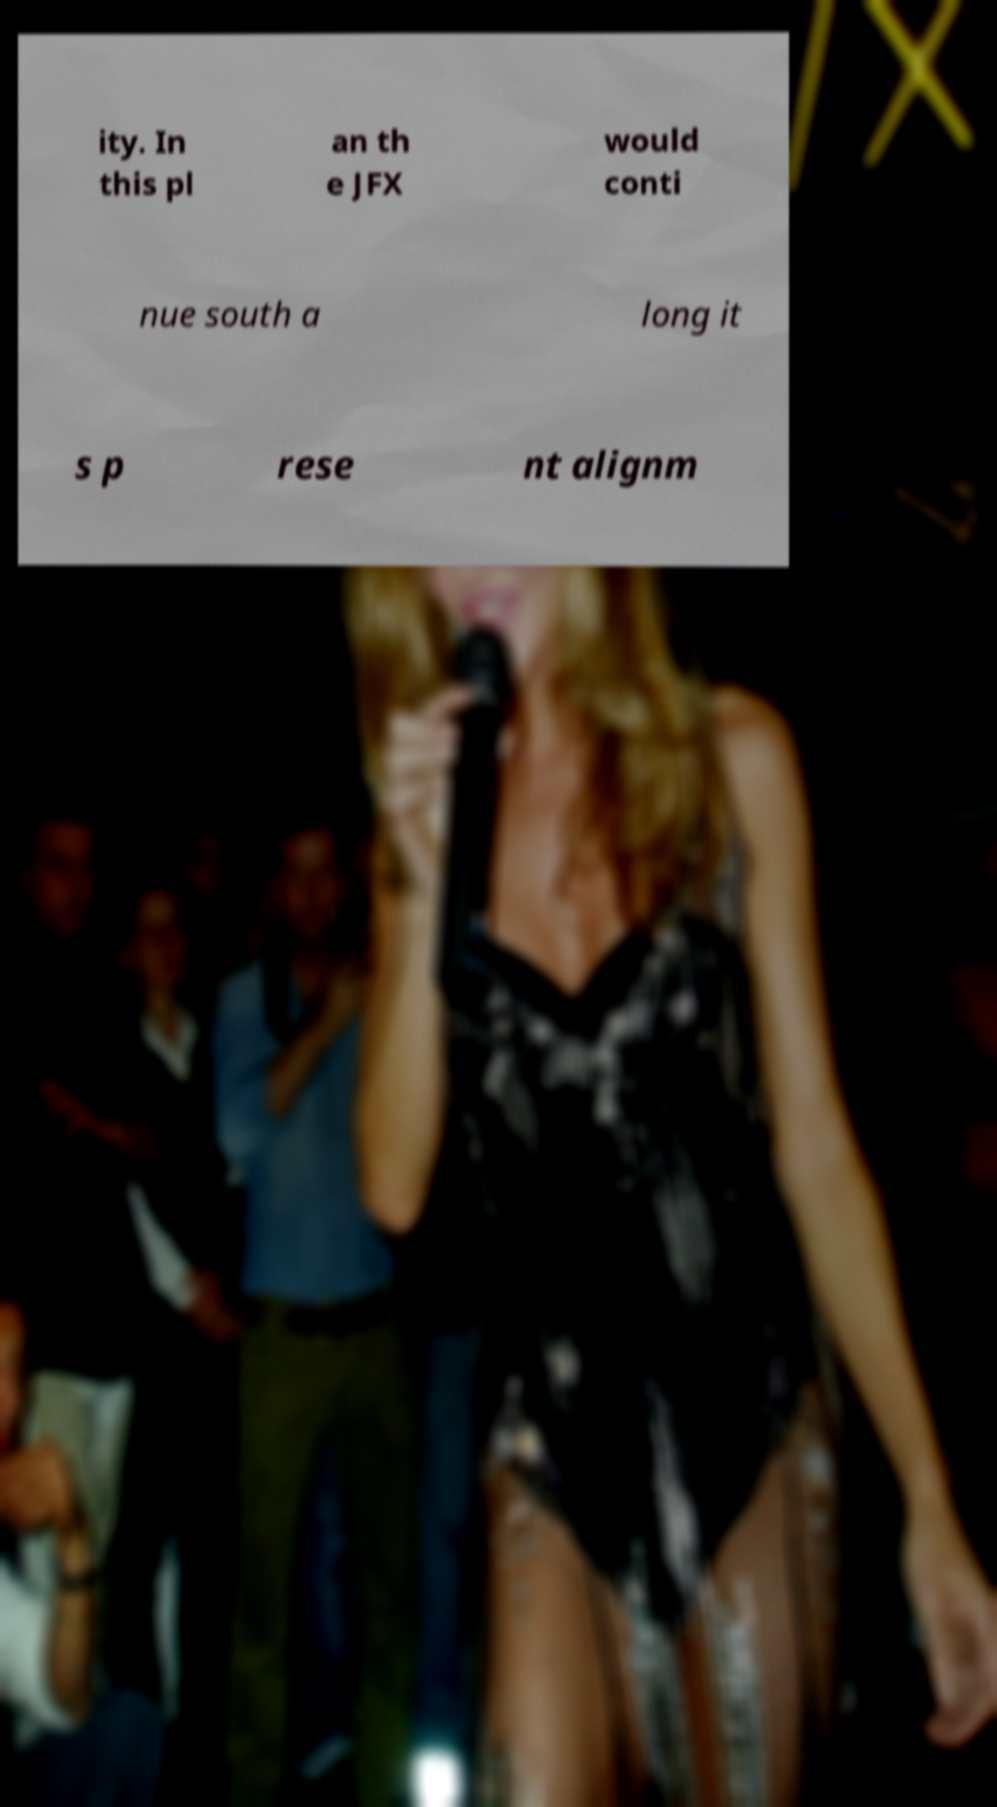Could you assist in decoding the text presented in this image and type it out clearly? ity. In this pl an th e JFX would conti nue south a long it s p rese nt alignm 